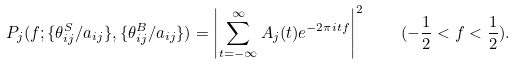Convert formula to latex. <formula><loc_0><loc_0><loc_500><loc_500>P _ { j } ( f ; \{ \theta _ { i j } ^ { S } / a _ { i j } \} , \{ \theta _ { i j } ^ { B } / a _ { i j } \} ) = \left | \sum _ { t = - \infty } ^ { \infty } A _ { j } ( t ) e ^ { - 2 \pi i t f } \right | ^ { 2 } \quad ( - \frac { 1 } { 2 } < f < \frac { 1 } { 2 } ) .</formula> 